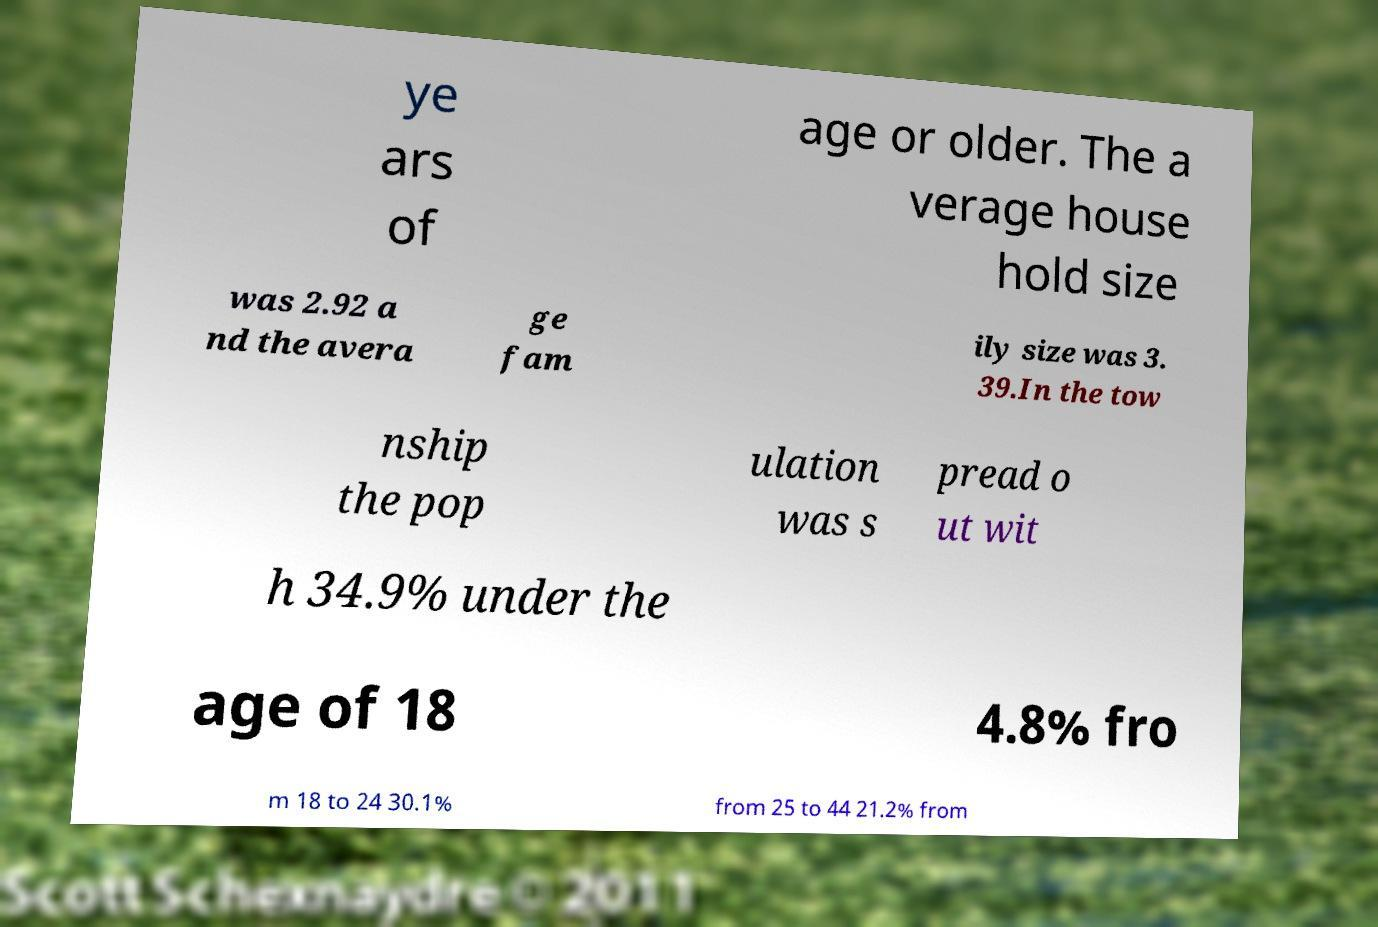Can you read and provide the text displayed in the image?This photo seems to have some interesting text. Can you extract and type it out for me? ye ars of age or older. The a verage house hold size was 2.92 a nd the avera ge fam ily size was 3. 39.In the tow nship the pop ulation was s pread o ut wit h 34.9% under the age of 18 4.8% fro m 18 to 24 30.1% from 25 to 44 21.2% from 